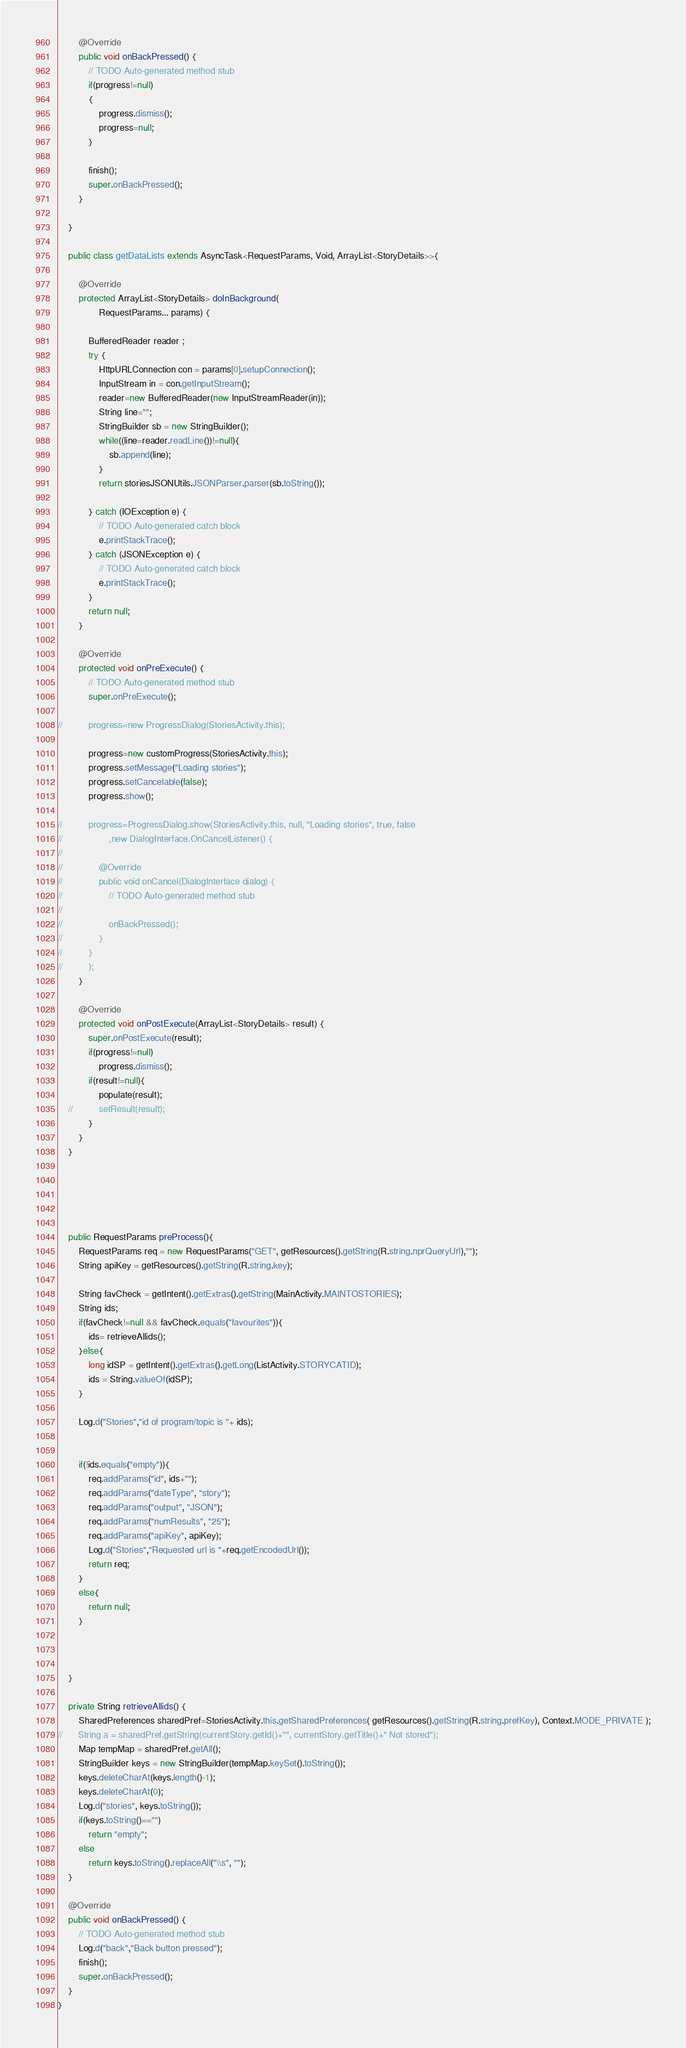<code> <loc_0><loc_0><loc_500><loc_500><_Java_>
		@Override
		public void onBackPressed() {
			// TODO Auto-generated method stub
			if(progress!=null)
			{	
				progress.dismiss();
				progress=null;
			}
			
			finish();
			super.onBackPressed();
		}
		
	}
	
	public class getDataLists extends AsyncTask<RequestParams, Void, ArrayList<StoryDetails>>{
		
		@Override
		protected ArrayList<StoryDetails> doInBackground(
				RequestParams... params) {
			
			BufferedReader reader ;
			try {
				HttpURLConnection con = params[0].setupConnection();
				InputStream in = con.getInputStream();
				reader=new BufferedReader(new InputStreamReader(in));
				String line="";
				StringBuilder sb = new StringBuilder();
				while((line=reader.readLine())!=null){
					sb.append(line);
				}
				return storiesJSONUtils.JSONParser.parser(sb.toString());
				
			} catch (IOException e) {
				// TODO Auto-generated catch block
				e.printStackTrace();
			} catch (JSONException e) {
				// TODO Auto-generated catch block
				e.printStackTrace();
			}
			return null;
		}

		@Override
		protected void onPreExecute() {
			// TODO Auto-generated method stub
			super.onPreExecute();
			
//			progress=new ProgressDialog(StoriesActivity.this);
			
			progress=new customProgress(StoriesActivity.this);
			progress.setMessage("Loading stories");
			progress.setCancelable(false);
			progress.show();
		
//			progress=ProgressDialog.show(StoriesActivity.this, null, "Loading stories", true, false
//					,new DialogInterface.OnCancelListener() {
//				
//				@Override
//				public void onCancel(DialogInterface dialog) {
//					// TODO Auto-generated method stub
//					
//					onBackPressed();
//				}
//			}
//			);
		}

		@Override
		protected void onPostExecute(ArrayList<StoryDetails> result) {
			super.onPostExecute(result);
			if(progress!=null)
				progress.dismiss();
			if(result!=null){
				populate(result);
	//			setResult(result);
			}
		}
	}
	

	


	public RequestParams preProcess(){
		RequestParams req = new RequestParams("GET", getResources().getString(R.string.nprQueryUrl),"");
		String apiKey = getResources().getString(R.string.key);
		
		String favCheck = getIntent().getExtras().getString(MainActivity.MAINTOSTORIES);
		String ids;
		if(favCheck!=null && favCheck.equals("favourites")){
			ids= retrieveAllids();
		}else{
			long idSP = getIntent().getExtras().getLong(ListActivity.STORYCATID);
			ids = String.valueOf(idSP);
		}		
		
		Log.d("Stories","id of program/topic is "+ ids);
		
		
		if(!ids.equals("empty")){
			req.addParams("id", ids+"");
			req.addParams("dateType", "story");
			req.addParams("output", "JSON");
			req.addParams("numResults", "25");
			req.addParams("apiKey", apiKey);
			Log.d("Stories","Requested url is "+req.getEncodedUrl());
			return req;
		}
		else{
			return null;
		}
		
		
		
	}

	private String retrieveAllids() {
		SharedPreferences sharedPref=StoriesActivity.this.getSharedPreferences( getResources().getString(R.string.prefKey), Context.MODE_PRIVATE );
//		String a = sharedPref.getString(currentStory.getId()+"", currentStory.getTitle()+" Not stored");
		Map tempMap = sharedPref.getAll();
		StringBuilder keys = new StringBuilder(tempMap.keySet().toString());
		keys.deleteCharAt(keys.length()-1);
		keys.deleteCharAt(0);
		Log.d("stories", keys.toString());
		if(keys.toString()=="")
			return "empty";
		else
			return keys.toString().replaceAll("\\s", "");
	}
	
	@Override
	public void onBackPressed() {
		// TODO Auto-generated method stub
		Log.d("back","Back button pressed");
		finish();
		super.onBackPressed();
	}
}
</code> 